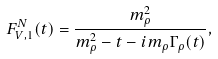Convert formula to latex. <formula><loc_0><loc_0><loc_500><loc_500>F ^ { N } _ { V , 1 } ( t ) = \frac { m _ { \rho } ^ { 2 } } { m _ { \rho } ^ { 2 } - t - i m _ { \rho } \Gamma _ { \rho } ( t ) } ,</formula> 